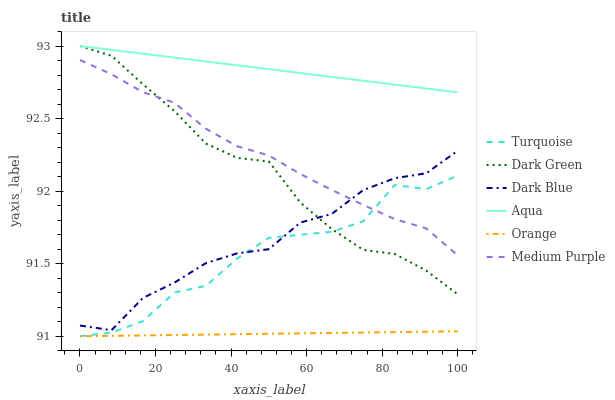Does Orange have the minimum area under the curve?
Answer yes or no. Yes. Does Aqua have the maximum area under the curve?
Answer yes or no. Yes. Does Medium Purple have the minimum area under the curve?
Answer yes or no. No. Does Medium Purple have the maximum area under the curve?
Answer yes or no. No. Is Orange the smoothest?
Answer yes or no. Yes. Is Turquoise the roughest?
Answer yes or no. Yes. Is Aqua the smoothest?
Answer yes or no. No. Is Aqua the roughest?
Answer yes or no. No. Does Turquoise have the lowest value?
Answer yes or no. Yes. Does Medium Purple have the lowest value?
Answer yes or no. No. Does Dark Green have the highest value?
Answer yes or no. Yes. Does Medium Purple have the highest value?
Answer yes or no. No. Is Orange less than Dark Blue?
Answer yes or no. Yes. Is Aqua greater than Dark Blue?
Answer yes or no. Yes. Does Medium Purple intersect Dark Blue?
Answer yes or no. Yes. Is Medium Purple less than Dark Blue?
Answer yes or no. No. Is Medium Purple greater than Dark Blue?
Answer yes or no. No. Does Orange intersect Dark Blue?
Answer yes or no. No. 